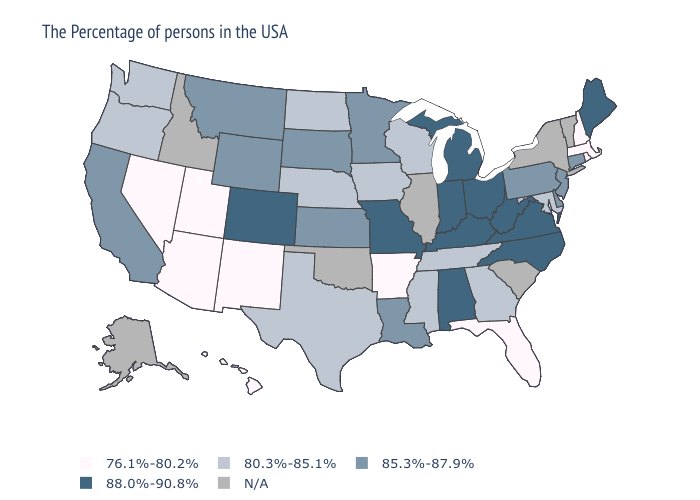Does the first symbol in the legend represent the smallest category?
Write a very short answer. Yes. Does Missouri have the highest value in the USA?
Keep it brief. Yes. What is the highest value in states that border Indiana?
Be succinct. 88.0%-90.8%. Which states have the highest value in the USA?
Concise answer only. Maine, Virginia, North Carolina, West Virginia, Ohio, Michigan, Kentucky, Indiana, Alabama, Missouri, Colorado. Which states have the lowest value in the USA?
Write a very short answer. Massachusetts, Rhode Island, New Hampshire, Florida, Arkansas, New Mexico, Utah, Arizona, Nevada, Hawaii. Among the states that border Minnesota , does South Dakota have the lowest value?
Write a very short answer. No. What is the lowest value in the South?
Short answer required. 76.1%-80.2%. Name the states that have a value in the range 85.3%-87.9%?
Write a very short answer. Connecticut, New Jersey, Delaware, Pennsylvania, Louisiana, Minnesota, Kansas, South Dakota, Wyoming, Montana, California. What is the highest value in the Northeast ?
Give a very brief answer. 88.0%-90.8%. What is the value of Oregon?
Concise answer only. 80.3%-85.1%. Does Hawaii have the highest value in the USA?
Give a very brief answer. No. Name the states that have a value in the range 88.0%-90.8%?
Concise answer only. Maine, Virginia, North Carolina, West Virginia, Ohio, Michigan, Kentucky, Indiana, Alabama, Missouri, Colorado. Among the states that border Illinois , which have the highest value?
Short answer required. Kentucky, Indiana, Missouri. Name the states that have a value in the range 76.1%-80.2%?
Answer briefly. Massachusetts, Rhode Island, New Hampshire, Florida, Arkansas, New Mexico, Utah, Arizona, Nevada, Hawaii. 